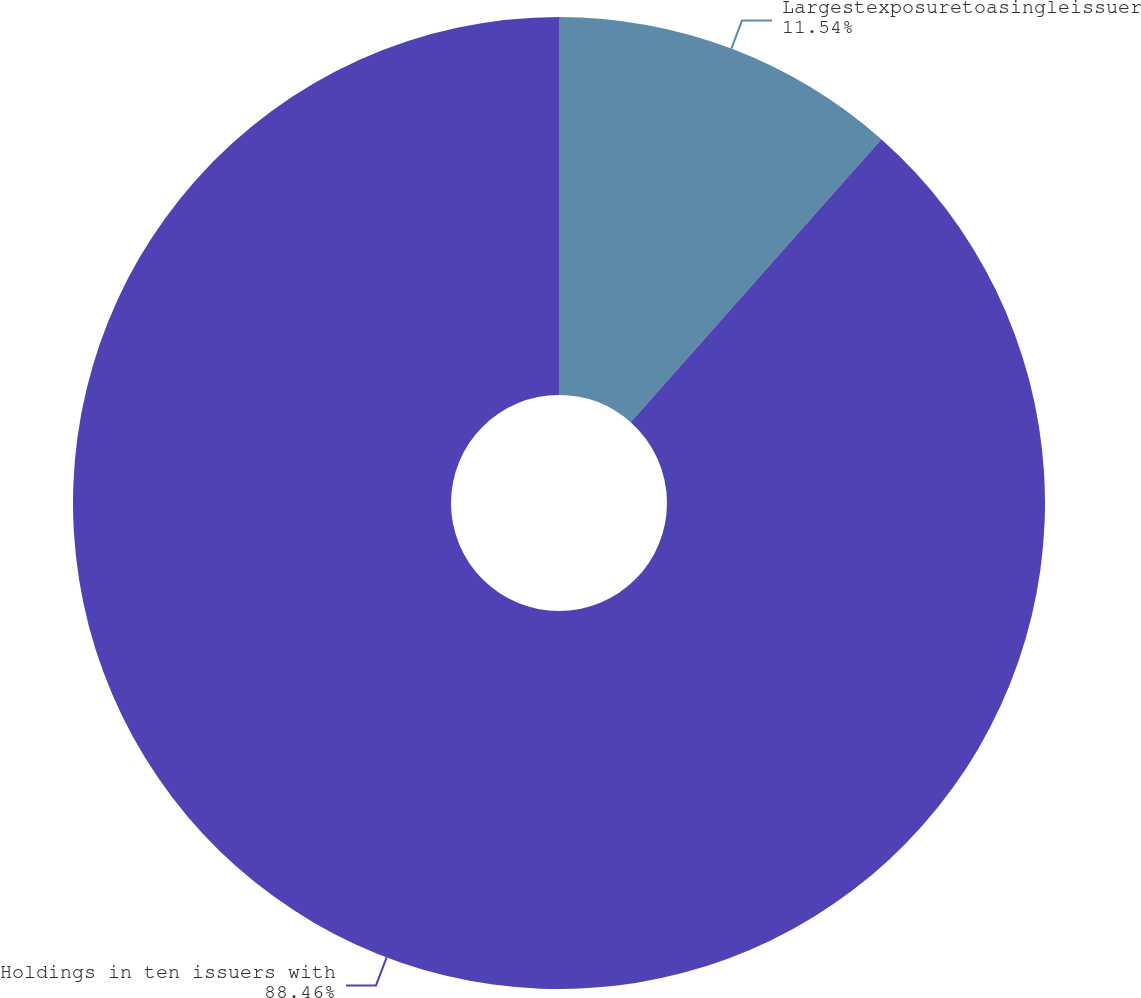Convert chart. <chart><loc_0><loc_0><loc_500><loc_500><pie_chart><fcel>Largestexposuretoasingleissuer<fcel>Holdings in ten issuers with<nl><fcel>11.54%<fcel>88.46%<nl></chart> 